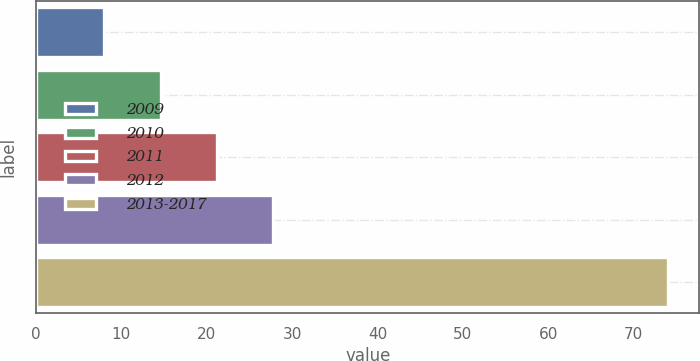Convert chart to OTSL. <chart><loc_0><loc_0><loc_500><loc_500><bar_chart><fcel>2009<fcel>2010<fcel>2011<fcel>2012<fcel>2013-2017<nl><fcel>8<fcel>14.6<fcel>21.2<fcel>27.8<fcel>74<nl></chart> 